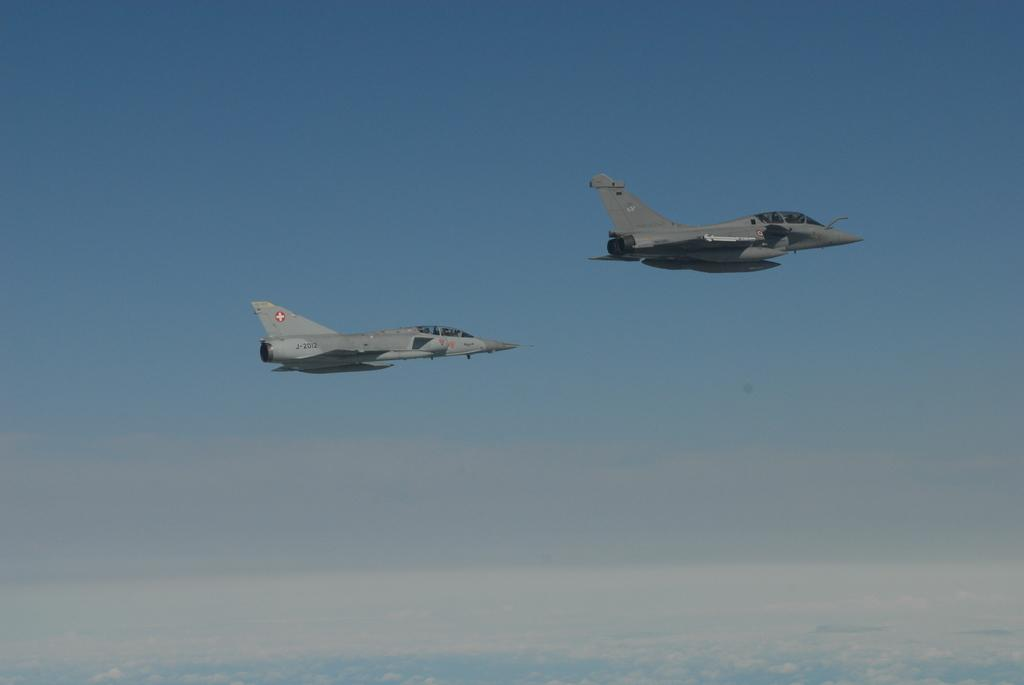What is the main subject of the image? The main subject of the image is two aircraft. Where are the aircraft located in the image? The aircraft are in the air in the image. What is the color of the sky in the image? The sky is blue in the image. What type of sofa can be seen in the image? There is no sofa present in the image; it features two aircraft in the air. What hour is depicted in the image? The image does not show a specific hour; it only shows two aircraft in the air and a blue sky. 